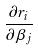Convert formula to latex. <formula><loc_0><loc_0><loc_500><loc_500>\frac { \partial r _ { i } } { \partial \beta _ { j } }</formula> 